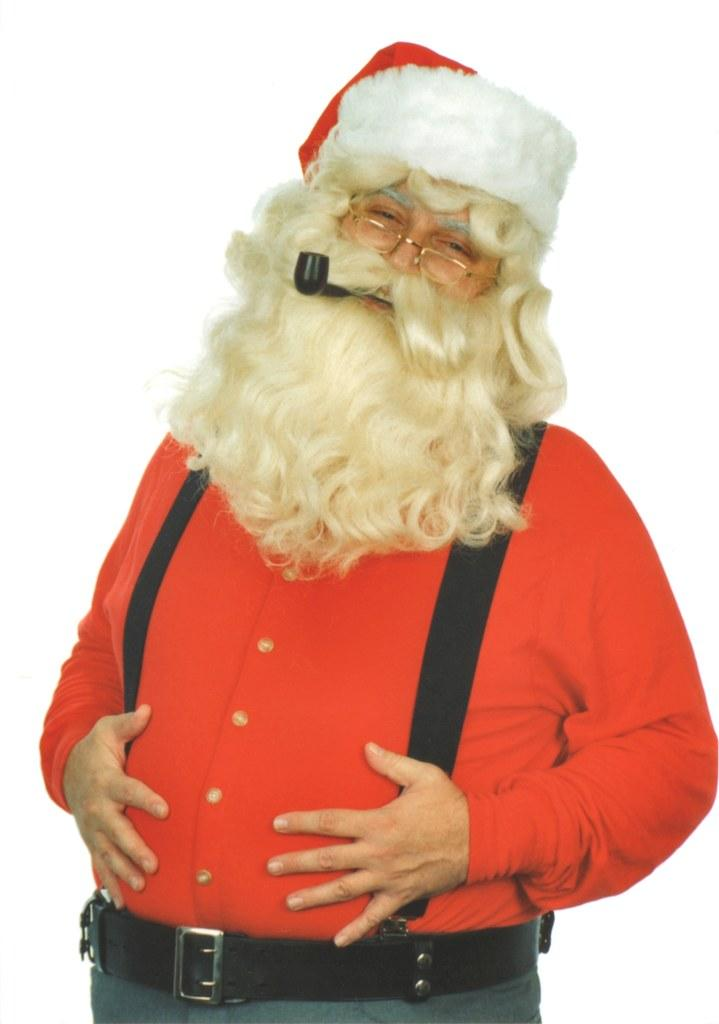Who or what is the main subject in the image? There is a person in the image. What is the person wearing on their face? The person is wearing a Santa Claus mask. What other accessories can be seen on the person? The person is wearing a cap and specs. What is the person holding in their mouth? The person has a smoking pipe in their mouth. What is the color of the background in the image? The background of the image is white. How many teeth can be seen in the image? There are no teeth visible in the image, as the person is wearing a Santa Claus mask that covers their face. What direction is the person turning in the image? There is no indication of the person turning in any direction in the image, as they appear to be standing still. 